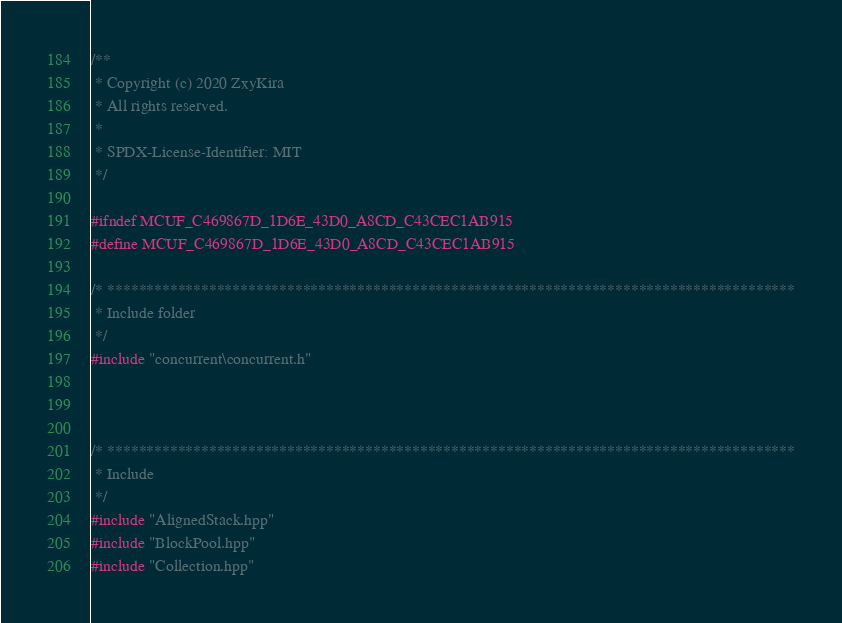<code> <loc_0><loc_0><loc_500><loc_500><_C_>/**
 * Copyright (c) 2020 ZxyKira
 * All rights reserved.
 * 
 * SPDX-License-Identifier: MIT
 */

#ifndef MCUF_C469867D_1D6E_43D0_A8CD_C43CEC1AB915
#define MCUF_C469867D_1D6E_43D0_A8CD_C43CEC1AB915

/* ****************************************************************************************
 * Include folder
 */
#include "concurrent\concurrent.h"



/* ****************************************************************************************
 * Include
 */
#include "AlignedStack.hpp"
#include "BlockPool.hpp"
#include "Collection.hpp"</code> 